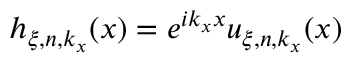<formula> <loc_0><loc_0><loc_500><loc_500>h _ { \xi , n , k _ { x } } ( x ) = e ^ { i k _ { x } x } u _ { \xi , n , k _ { x } } ( x )</formula> 